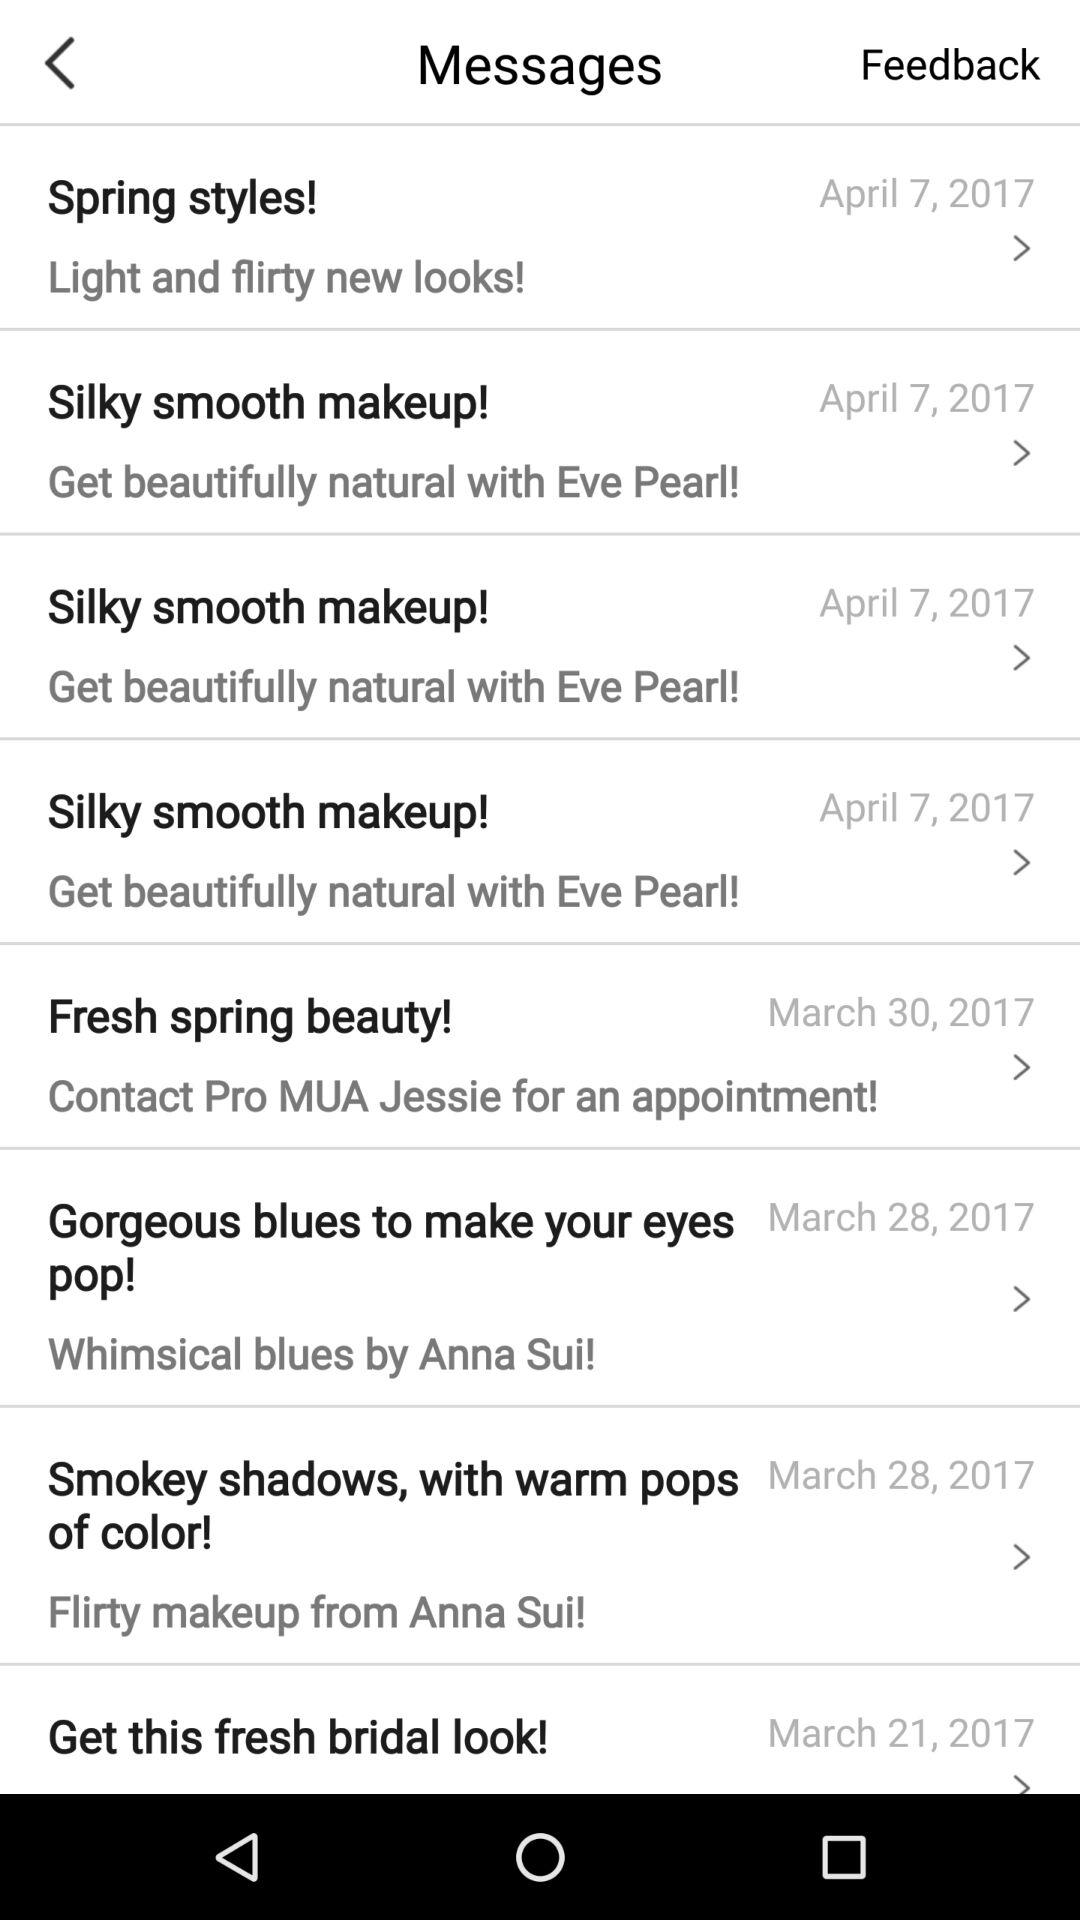What is the date of the "Spring Styles"? The date is April 7, 2017. 